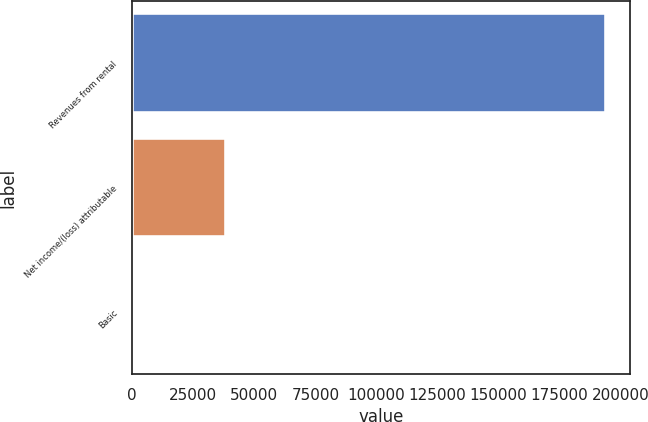Convert chart. <chart><loc_0><loc_0><loc_500><loc_500><bar_chart><fcel>Revenues from rental<fcel>Net income/(loss) attributable<fcel>Basic<nl><fcel>193895<fcel>38424<fcel>0.1<nl></chart> 